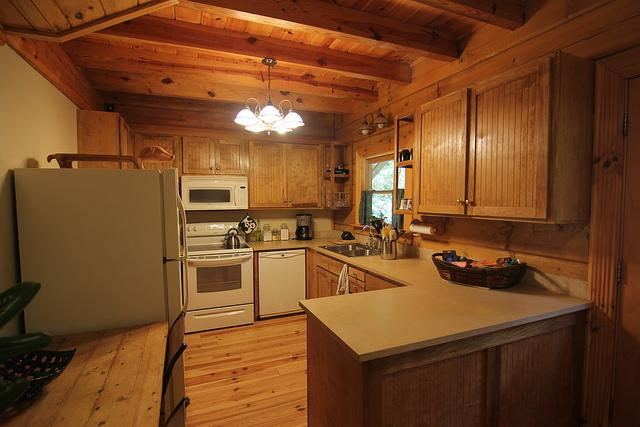What are the brightest lights attached to? Please explain your reasoning. ceiling. The lights are on the ceiling. 